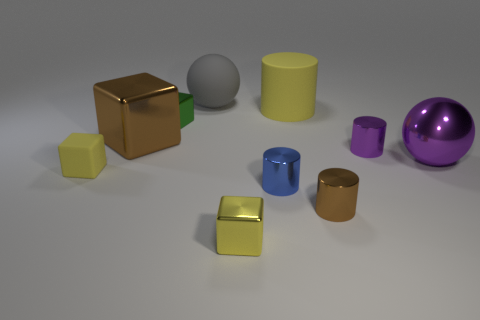What number of things are either objects to the left of the yellow shiny object or purple cylinders?
Your answer should be very brief. 5. The yellow object that is the same material as the big cylinder is what shape?
Provide a succinct answer. Cube. What number of yellow shiny objects are the same shape as the gray rubber thing?
Provide a succinct answer. 0. What is the material of the big yellow thing?
Keep it short and to the point. Rubber. There is a rubber cube; is its color the same as the big matte thing left of the rubber cylinder?
Make the answer very short. No. What number of blocks are brown rubber things or large brown things?
Make the answer very short. 1. What color is the big shiny object on the right side of the large cylinder?
Your response must be concise. Purple. There is a tiny object that is the same color as the shiny sphere; what is its shape?
Keep it short and to the point. Cylinder. What number of other yellow things are the same size as the yellow shiny thing?
Offer a terse response. 1. Is the shape of the yellow matte object to the left of the large cylinder the same as the big thing behind the large yellow matte cylinder?
Offer a very short reply. No. 